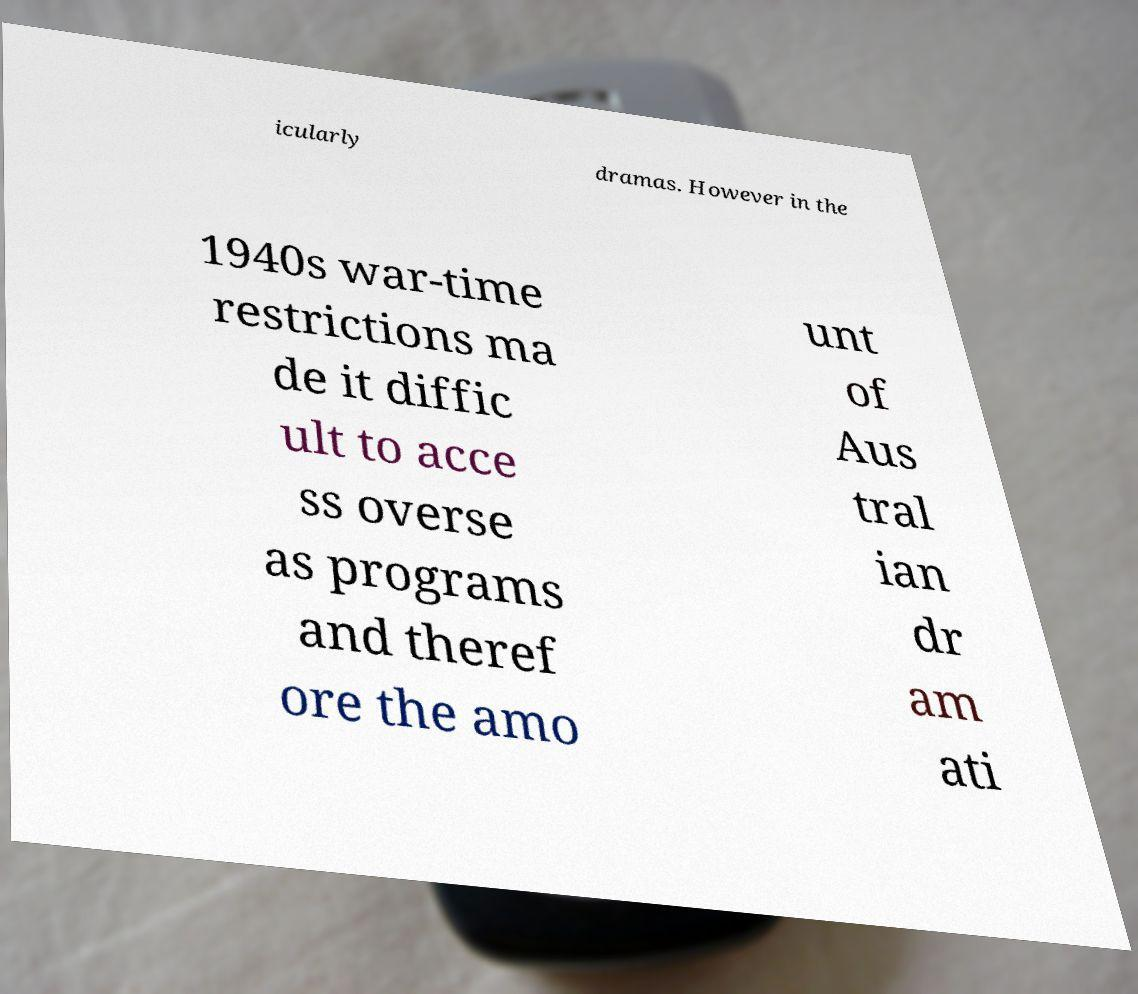Could you extract and type out the text from this image? icularly dramas. However in the 1940s war-time restrictions ma de it diffic ult to acce ss overse as programs and theref ore the amo unt of Aus tral ian dr am ati 